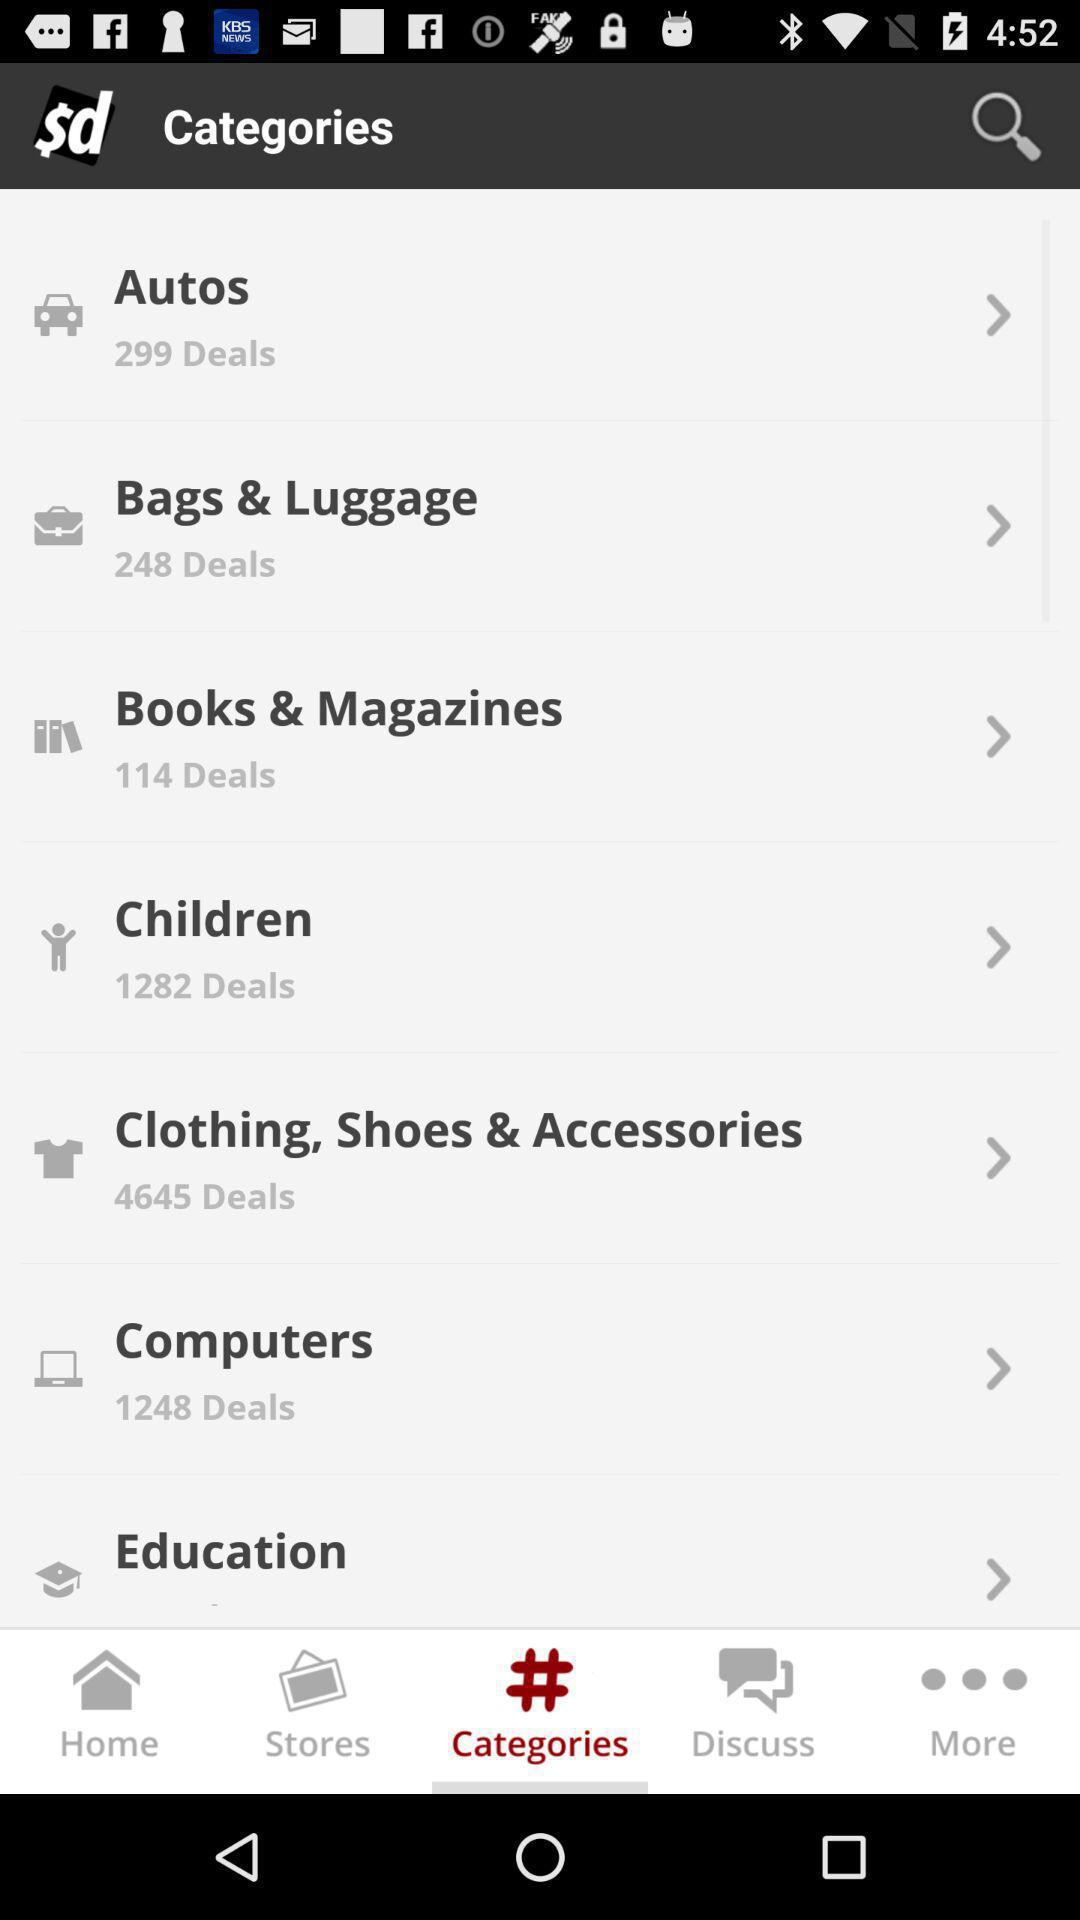What is the number of deals in books and magazines? There are 114 deals in books and magazines. 